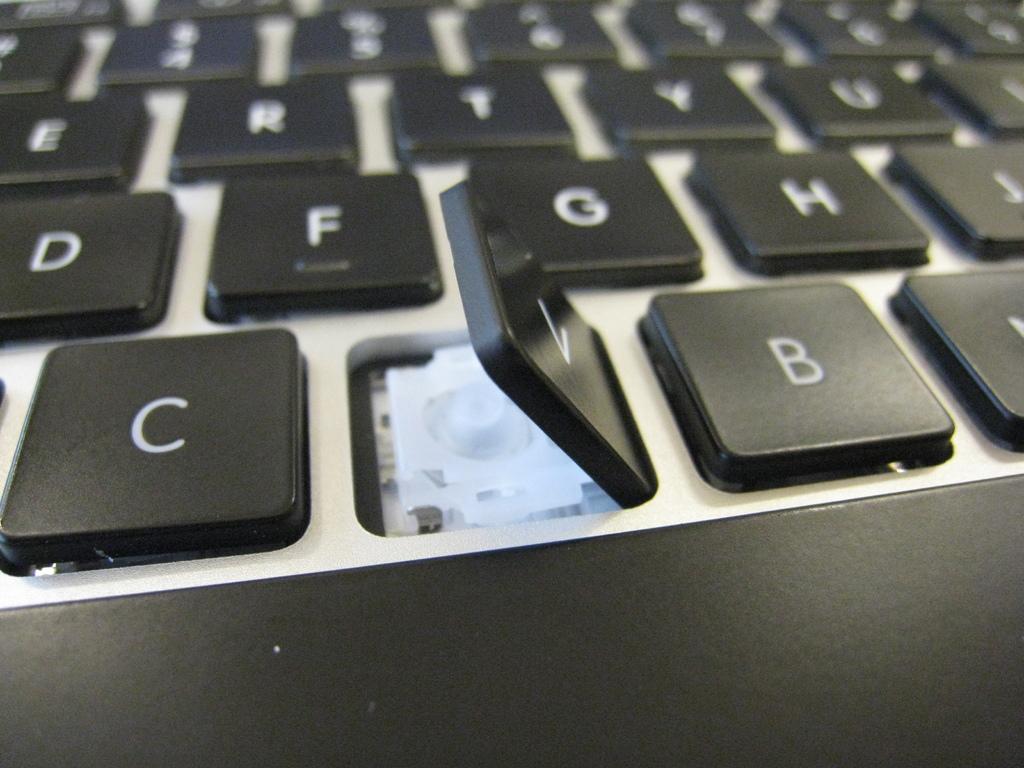What key is being pulled off?
Offer a terse response. V. 